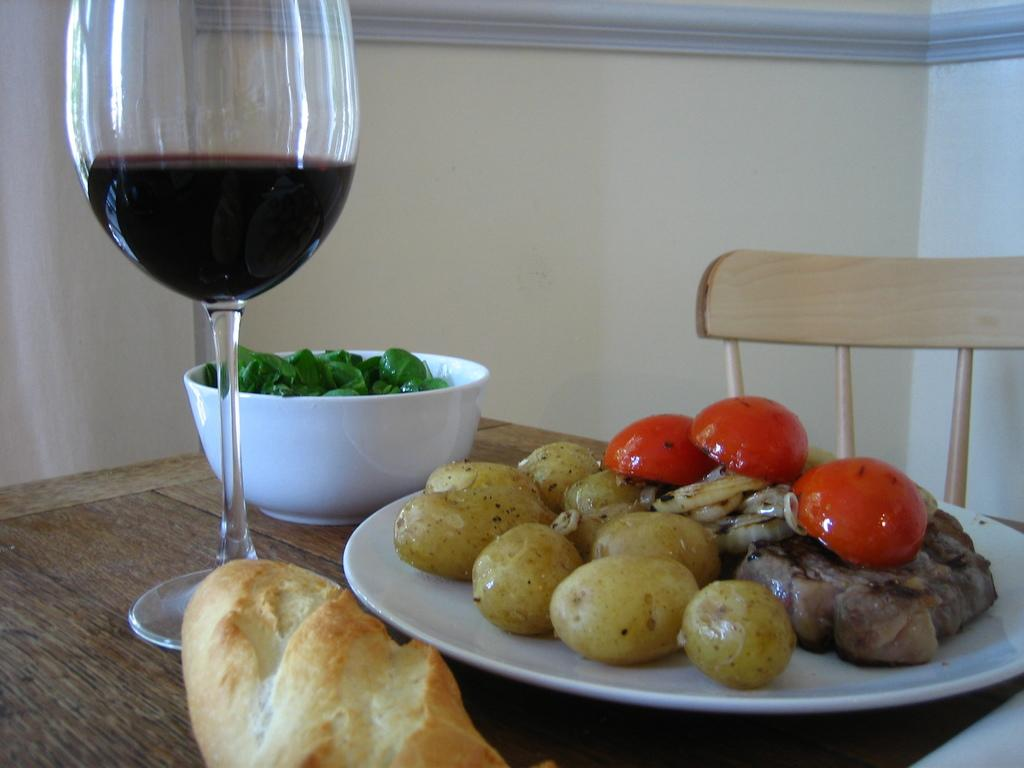What type of furniture is present in the image? There is a table and a chair in the image. What items can be seen on the table? There is a wine glass, a bowl filled with greens, a serving plate with food, and a bread on the table. What might be used for drinking in the image? The wine glass on the table might be used for drinking. What type of food is visible on the serving plate? The type of food on the serving plate is not specified in the facts. What color is the orange on the table in the image? There is no orange present on the table in the image. Can you tell me where the shop is located in the image? There is no shop present in the image. 